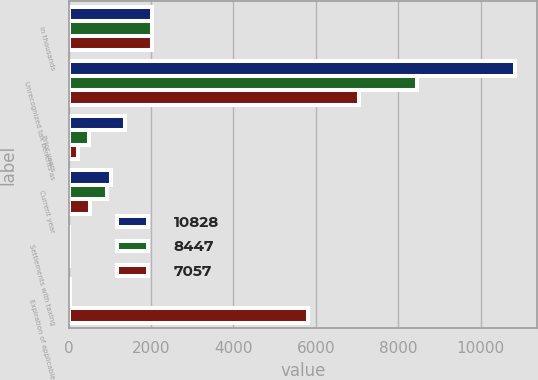<chart> <loc_0><loc_0><loc_500><loc_500><stacked_bar_chart><ecel><fcel>in thousands<fcel>Unrecognized tax benefits as<fcel>Prior years<fcel>Current year<fcel>Settlements with taxing<fcel>Expiration of applicable<nl><fcel>10828<fcel>2016<fcel>10828<fcel>1368<fcel>1040<fcel>0<fcel>27<nl><fcel>8447<fcel>2015<fcel>8447<fcel>491<fcel>942<fcel>0<fcel>43<nl><fcel>7057<fcel>2014<fcel>7057<fcel>229<fcel>528<fcel>0<fcel>5802<nl></chart> 